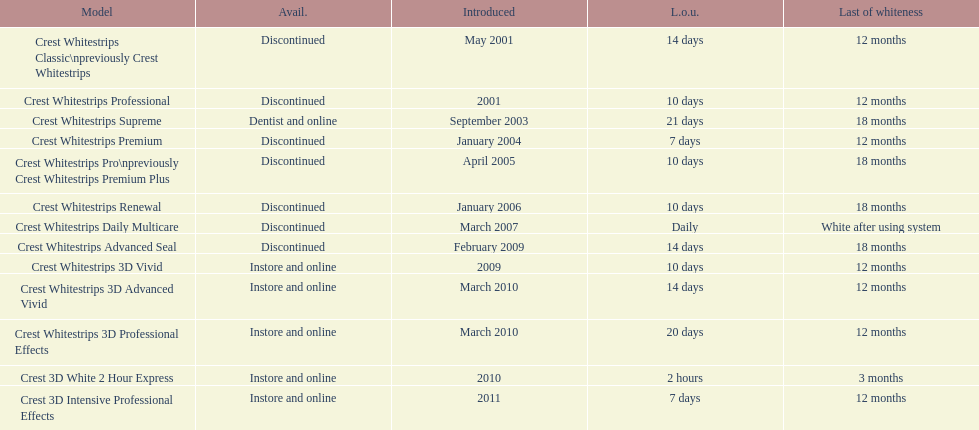Does the crest white strips classic last at least one year? Yes. 